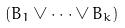<formula> <loc_0><loc_0><loc_500><loc_500>( B _ { 1 } \vee \cdot \cdot \cdot \vee B _ { k } )</formula> 